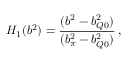<formula> <loc_0><loc_0><loc_500><loc_500>H _ { 1 } ( b ^ { 2 } ) = \frac { ( b ^ { 2 } - b _ { Q 0 } ^ { 2 } ) } { ( b _ { \pi } ^ { 2 } - b _ { Q 0 } ^ { 2 } ) } \, ,</formula> 